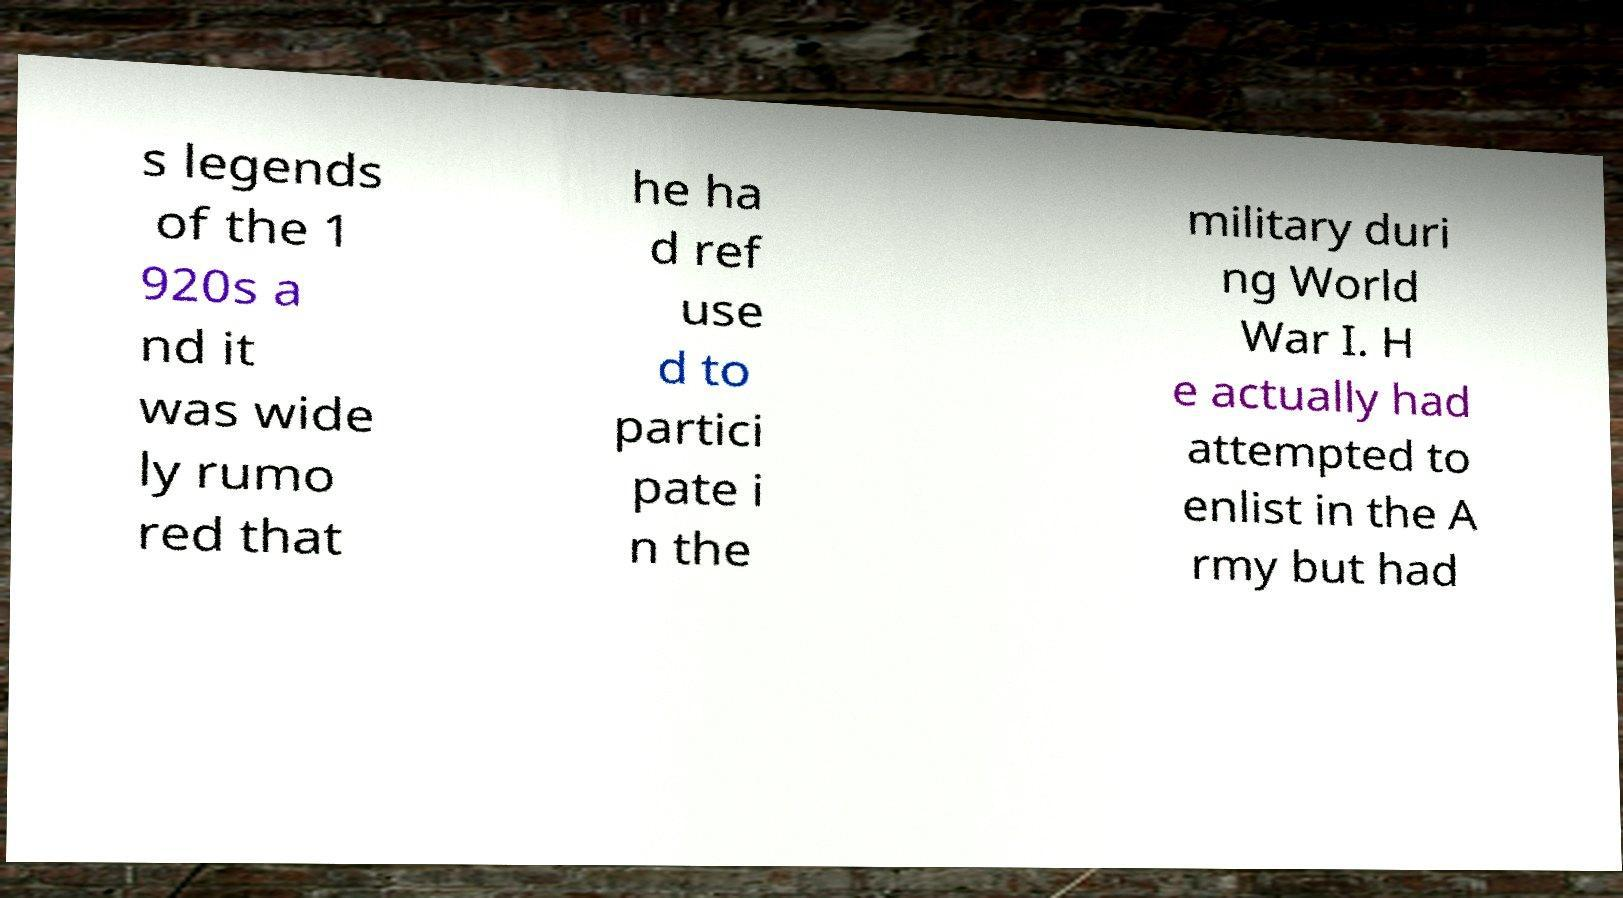Could you extract and type out the text from this image? s legends of the 1 920s a nd it was wide ly rumo red that he ha d ref use d to partici pate i n the military duri ng World War I. H e actually had attempted to enlist in the A rmy but had 